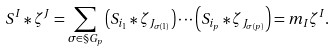Convert formula to latex. <formula><loc_0><loc_0><loc_500><loc_500>S ^ { I } * \zeta ^ { J } & = \sum _ { \sigma \in \S G _ { p } } \left ( S _ { i _ { 1 } } * \zeta _ { J _ { \sigma ( 1 ) } } \right ) \cdots \left ( S _ { i _ { p } } * \zeta _ { J _ { \sigma ( p ) } } \right ) = m _ { I } \zeta ^ { I } .</formula> 